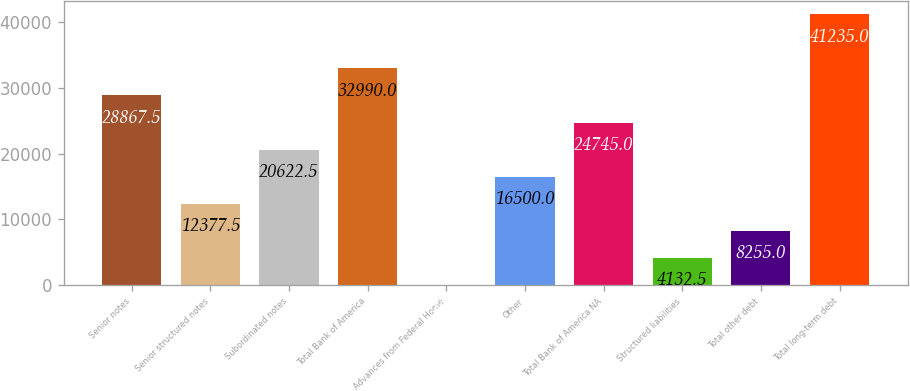Convert chart to OTSL. <chart><loc_0><loc_0><loc_500><loc_500><bar_chart><fcel>Senior notes<fcel>Senior structured notes<fcel>Subordinated notes<fcel>Total Bank of America<fcel>Advances from Federal Home<fcel>Other<fcel>Total Bank of America NA<fcel>Structured liabilities<fcel>Total other debt<fcel>Total long-term debt<nl><fcel>28867.5<fcel>12377.5<fcel>20622.5<fcel>32990<fcel>10<fcel>16500<fcel>24745<fcel>4132.5<fcel>8255<fcel>41235<nl></chart> 